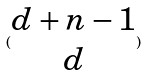<formula> <loc_0><loc_0><loc_500><loc_500>( \begin{matrix} d + n - 1 \\ d \end{matrix} )</formula> 